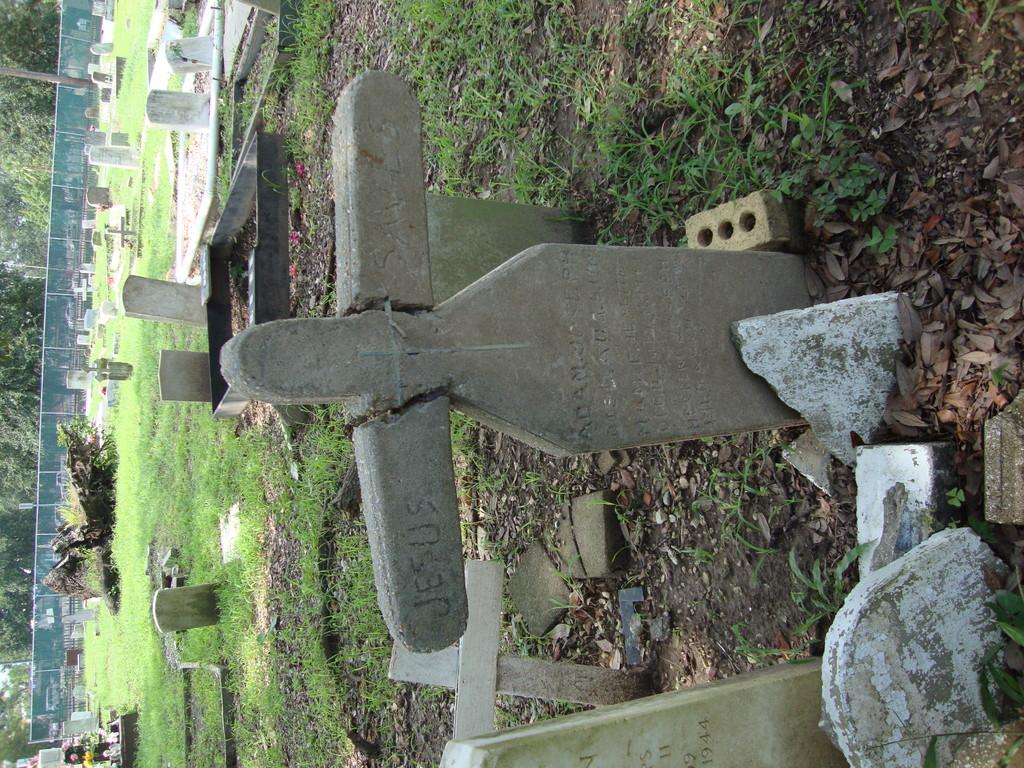What is the main subject in the center of the image? There is a gravestone in the center of the image. What type of vegetation is present in the image? Grass is present in the image. What additional objects can be seen on the ground? Dry leaves and stones are visible in the image. What is located on the left side of the image? There is a mesh and trees on the left side of the image. What is the price of the achiever's latest book in the image? There is no achiever or book present in the image; it features a gravestone and other outdoor elements. 